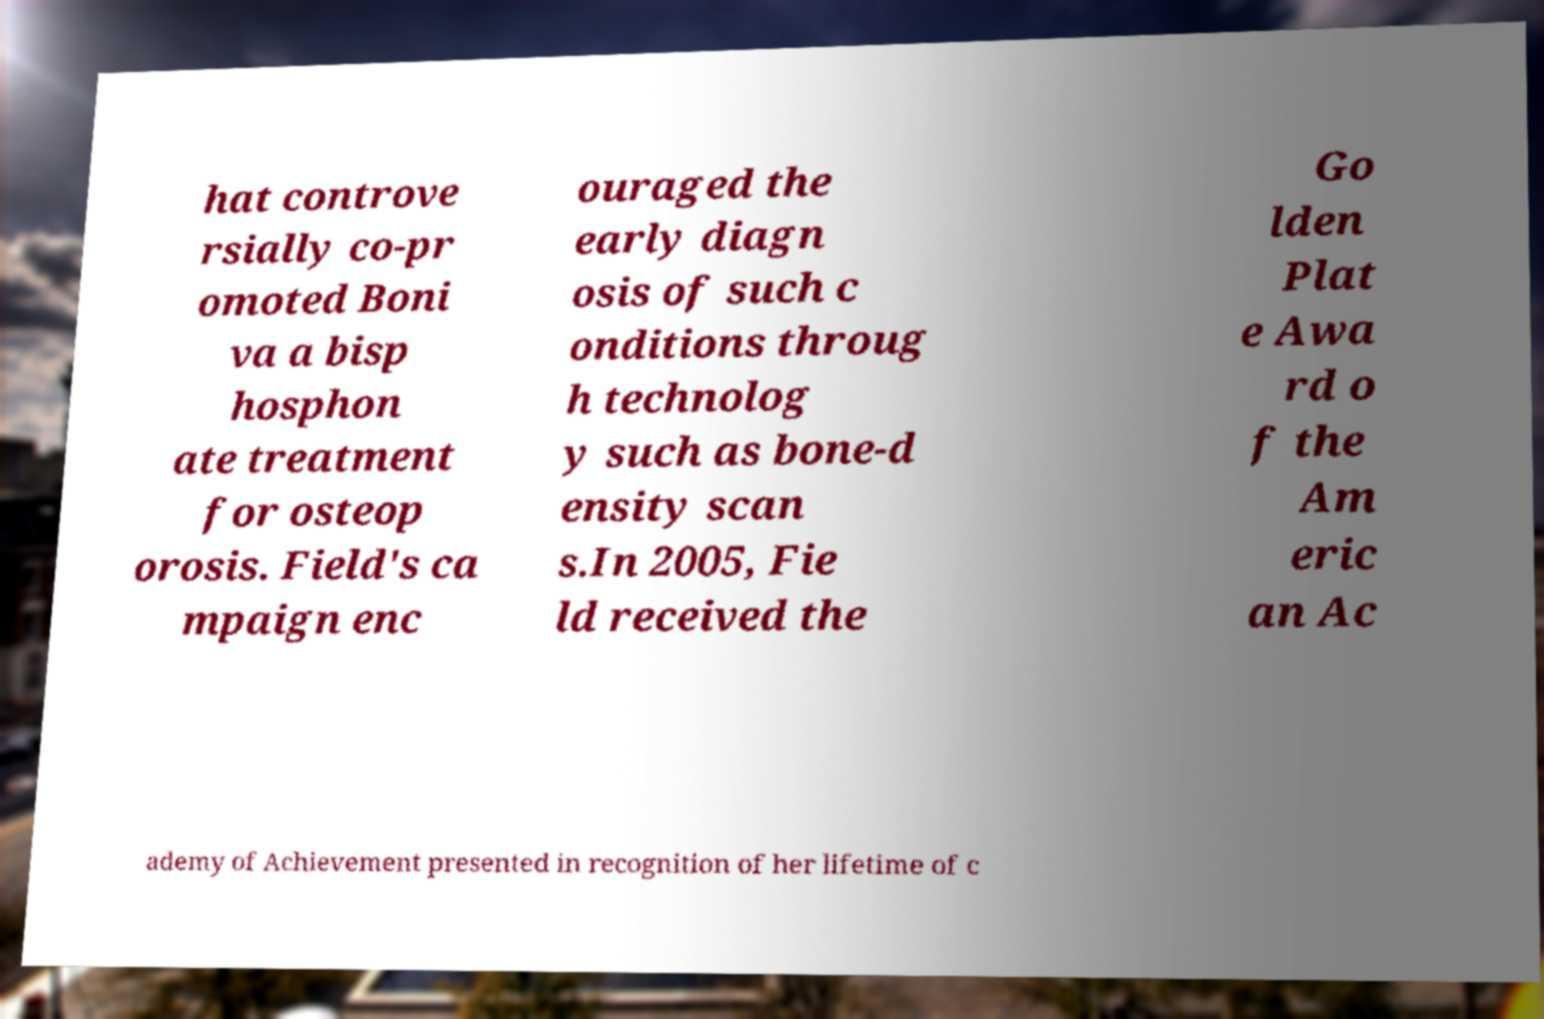Please read and relay the text visible in this image. What does it say? hat controve rsially co-pr omoted Boni va a bisp hosphon ate treatment for osteop orosis. Field's ca mpaign enc ouraged the early diagn osis of such c onditions throug h technolog y such as bone-d ensity scan s.In 2005, Fie ld received the Go lden Plat e Awa rd o f the Am eric an Ac ademy of Achievement presented in recognition of her lifetime of c 